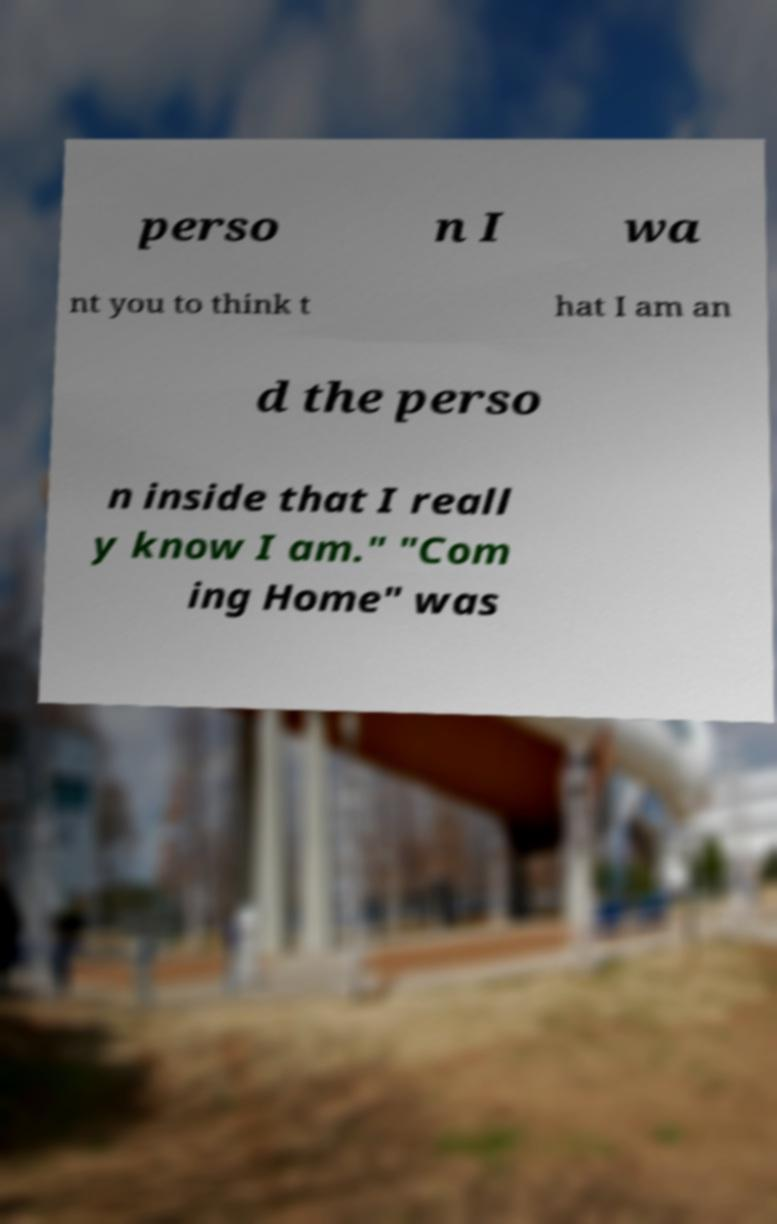I need the written content from this picture converted into text. Can you do that? perso n I wa nt you to think t hat I am an d the perso n inside that I reall y know I am." "Com ing Home" was 